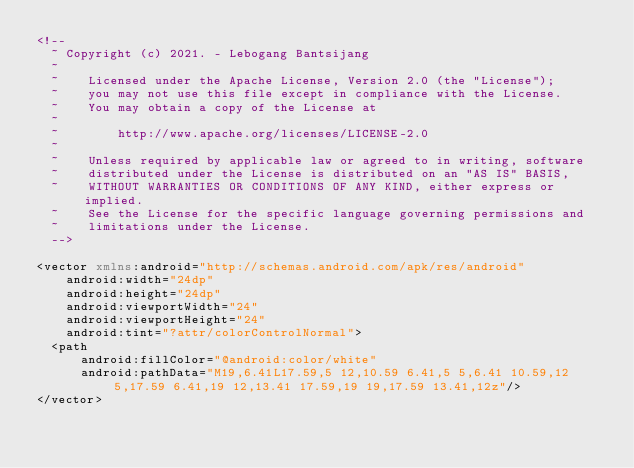<code> <loc_0><loc_0><loc_500><loc_500><_XML_><!--
  ~ Copyright (c) 2021. - Lebogang Bantsijang
  ~
  ~    Licensed under the Apache License, Version 2.0 (the "License");
  ~    you may not use this file except in compliance with the License.
  ~    You may obtain a copy of the License at
  ~
  ~        http://www.apache.org/licenses/LICENSE-2.0
  ~
  ~    Unless required by applicable law or agreed to in writing, software
  ~    distributed under the License is distributed on an "AS IS" BASIS,
  ~    WITHOUT WARRANTIES OR CONDITIONS OF ANY KIND, either express or implied.
  ~    See the License for the specific language governing permissions and
  ~    limitations under the License.
  -->

<vector xmlns:android="http://schemas.android.com/apk/res/android"
    android:width="24dp"
    android:height="24dp"
    android:viewportWidth="24"
    android:viewportHeight="24"
    android:tint="?attr/colorControlNormal">
  <path
      android:fillColor="@android:color/white"
      android:pathData="M19,6.41L17.59,5 12,10.59 6.41,5 5,6.41 10.59,12 5,17.59 6.41,19 12,13.41 17.59,19 19,17.59 13.41,12z"/>
</vector>
</code> 